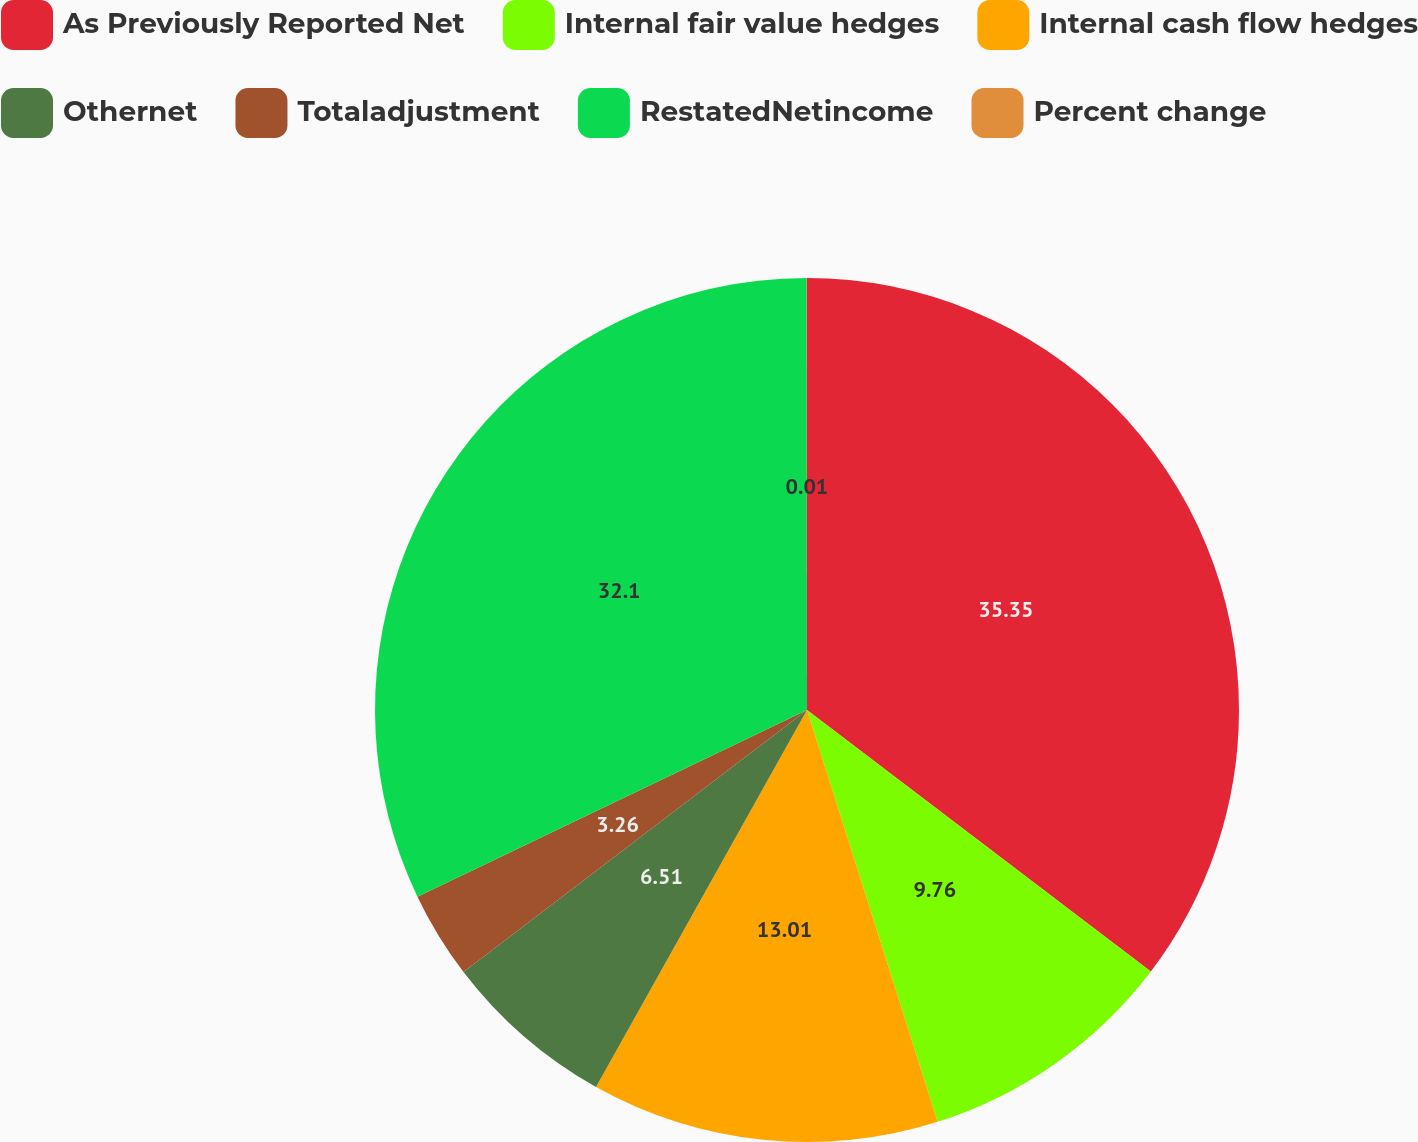Convert chart to OTSL. <chart><loc_0><loc_0><loc_500><loc_500><pie_chart><fcel>As Previously Reported Net<fcel>Internal fair value hedges<fcel>Internal cash flow hedges<fcel>Othernet<fcel>Totaladjustment<fcel>RestatedNetincome<fcel>Percent change<nl><fcel>35.35%<fcel>9.76%<fcel>13.01%<fcel>6.51%<fcel>3.26%<fcel>32.1%<fcel>0.01%<nl></chart> 